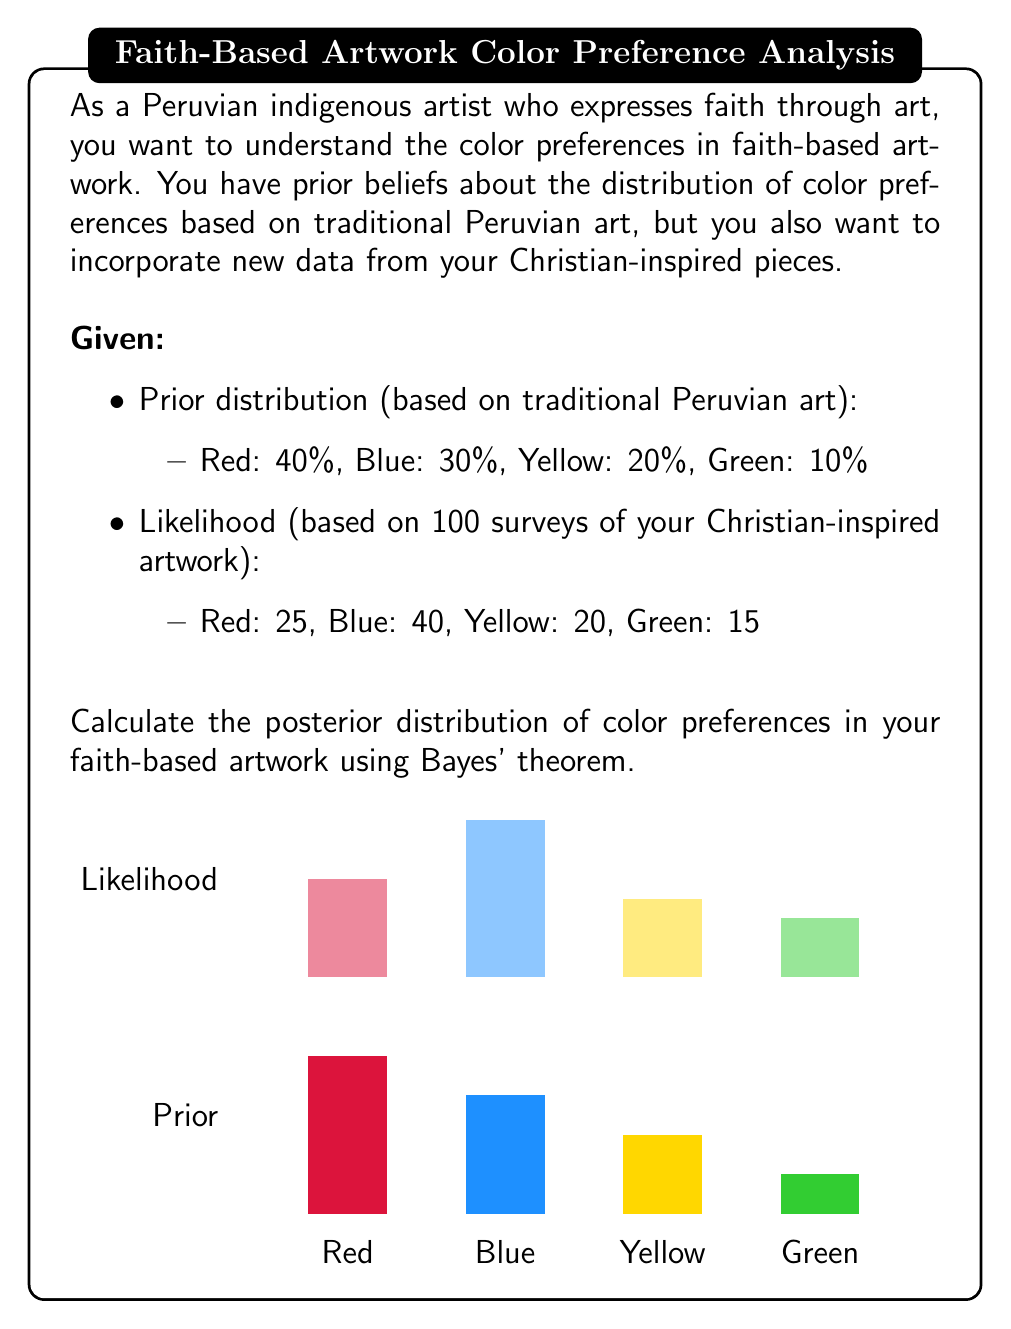Teach me how to tackle this problem. To calculate the posterior distribution using Bayes' theorem, we follow these steps:

1. Define the prior probabilities:
   $P(Red) = 0.4$, $P(Blue) = 0.3$, $P(Yellow) = 0.2$, $P(Green) = 0.1$

2. Calculate the likelihood for each color:
   $L(Red) = 25/100 = 0.25$
   $L(Blue) = 40/100 = 0.40$
   $L(Yellow) = 20/100 = 0.20$
   $L(Green) = 15/100 = 0.15$

3. Calculate the evidence (marginal likelihood):
   $P(E) = \sum_{i} P(Color_i) \cdot L(Color_i)$
   $P(E) = 0.4 \cdot 0.25 + 0.3 \cdot 0.40 + 0.2 \cdot 0.20 + 0.1 \cdot 0.15 = 0.295$

4. Apply Bayes' theorem for each color:
   $P(Color|E) = \frac{P(Color) \cdot L(Color)}{P(E)}$

   For Red:
   $P(Red|E) = \frac{0.4 \cdot 0.25}{0.295} \approx 0.3390$

   For Blue:
   $P(Blue|E) = \frac{0.3 \cdot 0.40}{0.295} \approx 0.4068$

   For Yellow:
   $P(Yellow|E) = \frac{0.2 \cdot 0.20}{0.295} \approx 0.1356$

   For Green:
   $P(Green|E) = \frac{0.1 \cdot 0.15}{0.295} \approx 0.0508$

5. Normalize the probabilities to ensure they sum to 1:
   Total = 0.3390 + 0.4068 + 0.1356 + 0.0508 = 0.9322

   Red: 0.3390 / 0.9322 ≈ 0.3637 or 36.37%
   Blue: 0.4068 / 0.9322 ≈ 0.4364 or 43.64%
   Yellow: 0.1356 / 0.9322 ≈ 0.1455 or 14.55%
   Green: 0.0508 / 0.9322 ≈ 0.0545 or 5.45%
Answer: Posterior distribution: Red: 36.37%, Blue: 43.64%, Yellow: 14.55%, Green: 5.45% 